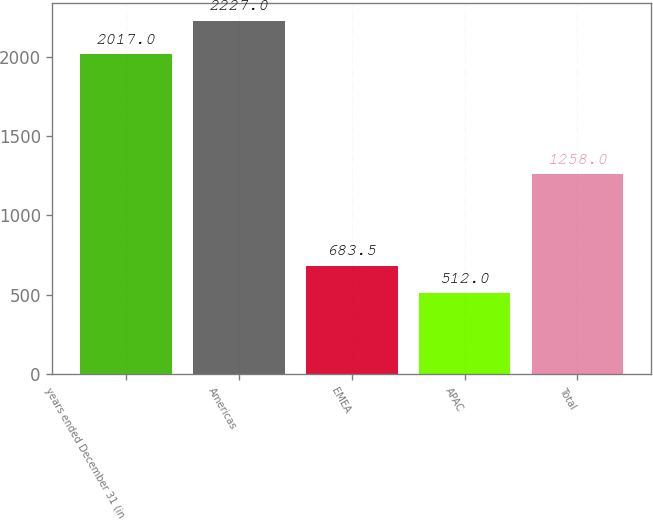<chart> <loc_0><loc_0><loc_500><loc_500><bar_chart><fcel>years ended December 31 (in<fcel>Americas<fcel>EMEA<fcel>APAC<fcel>Total<nl><fcel>2017<fcel>2227<fcel>683.5<fcel>512<fcel>1258<nl></chart> 